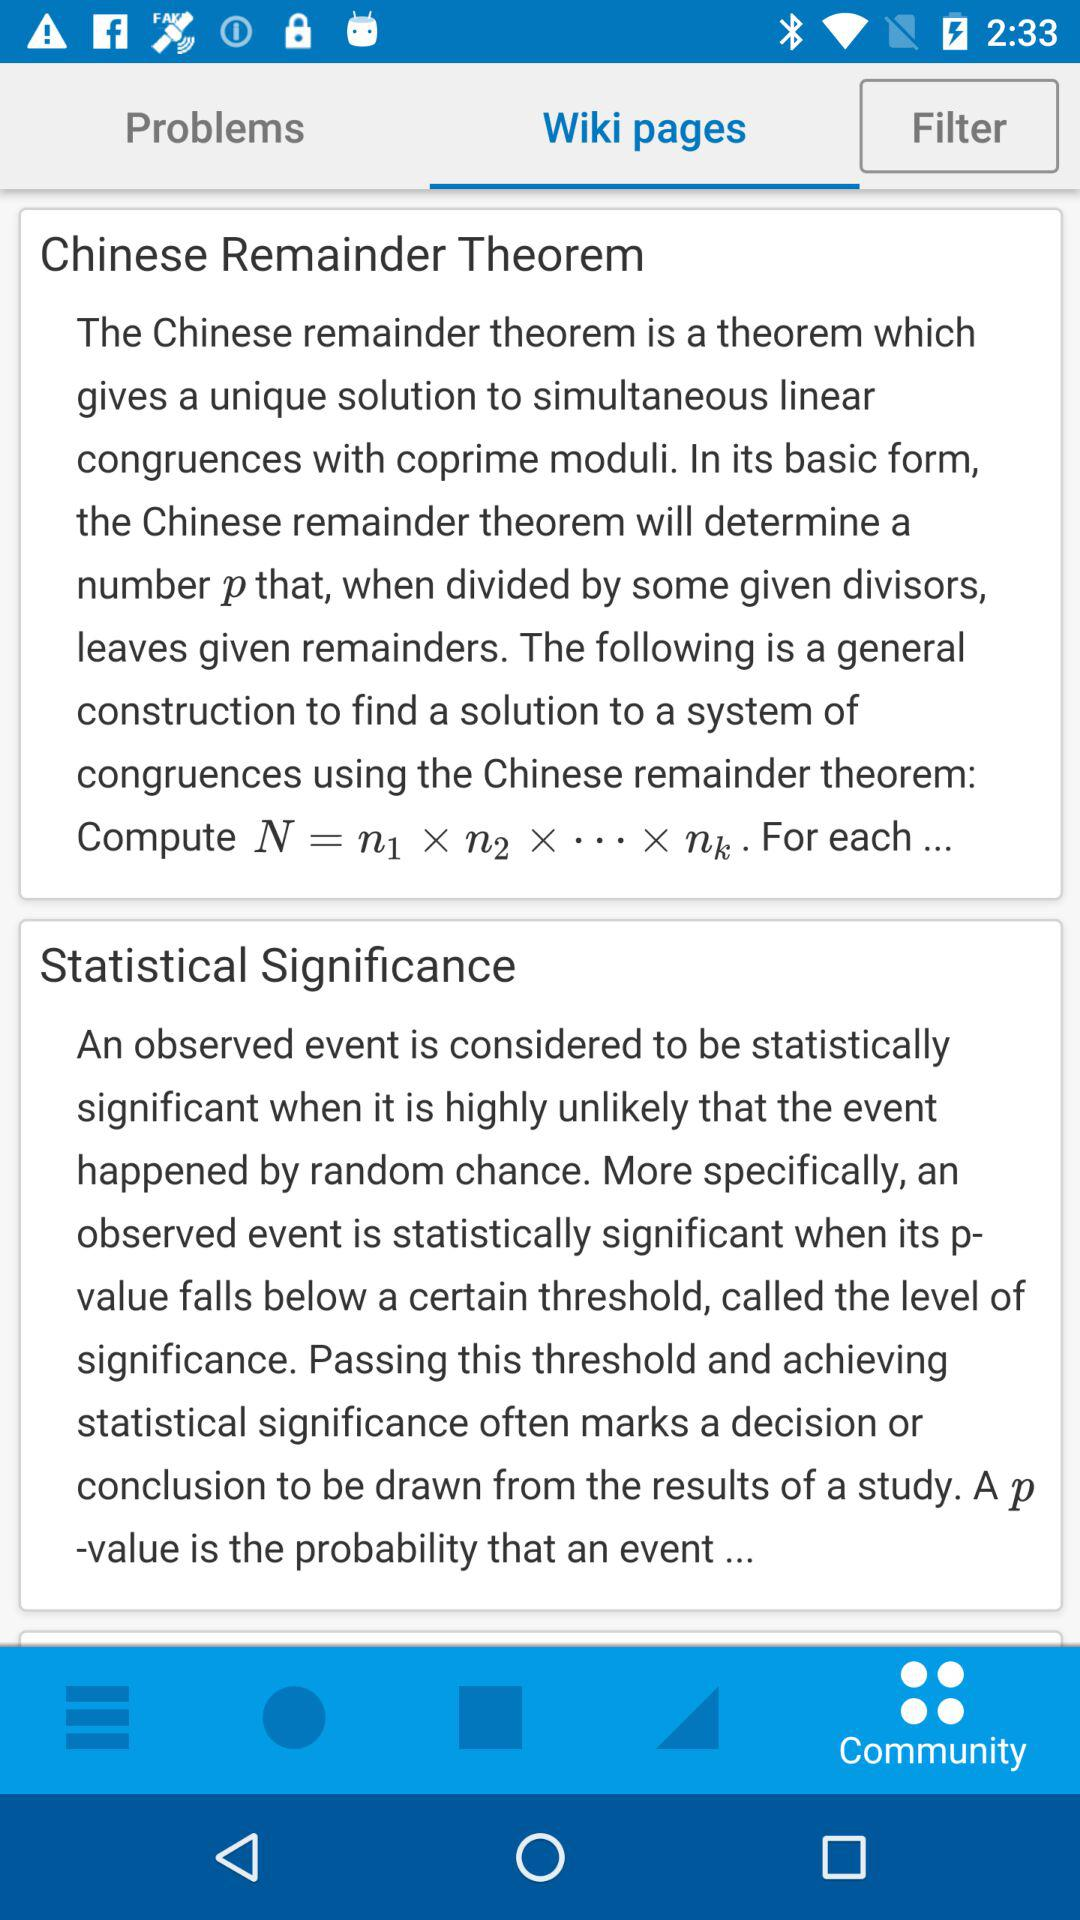Which option is selected? The selected options are "Wiki pages" and "Community". 